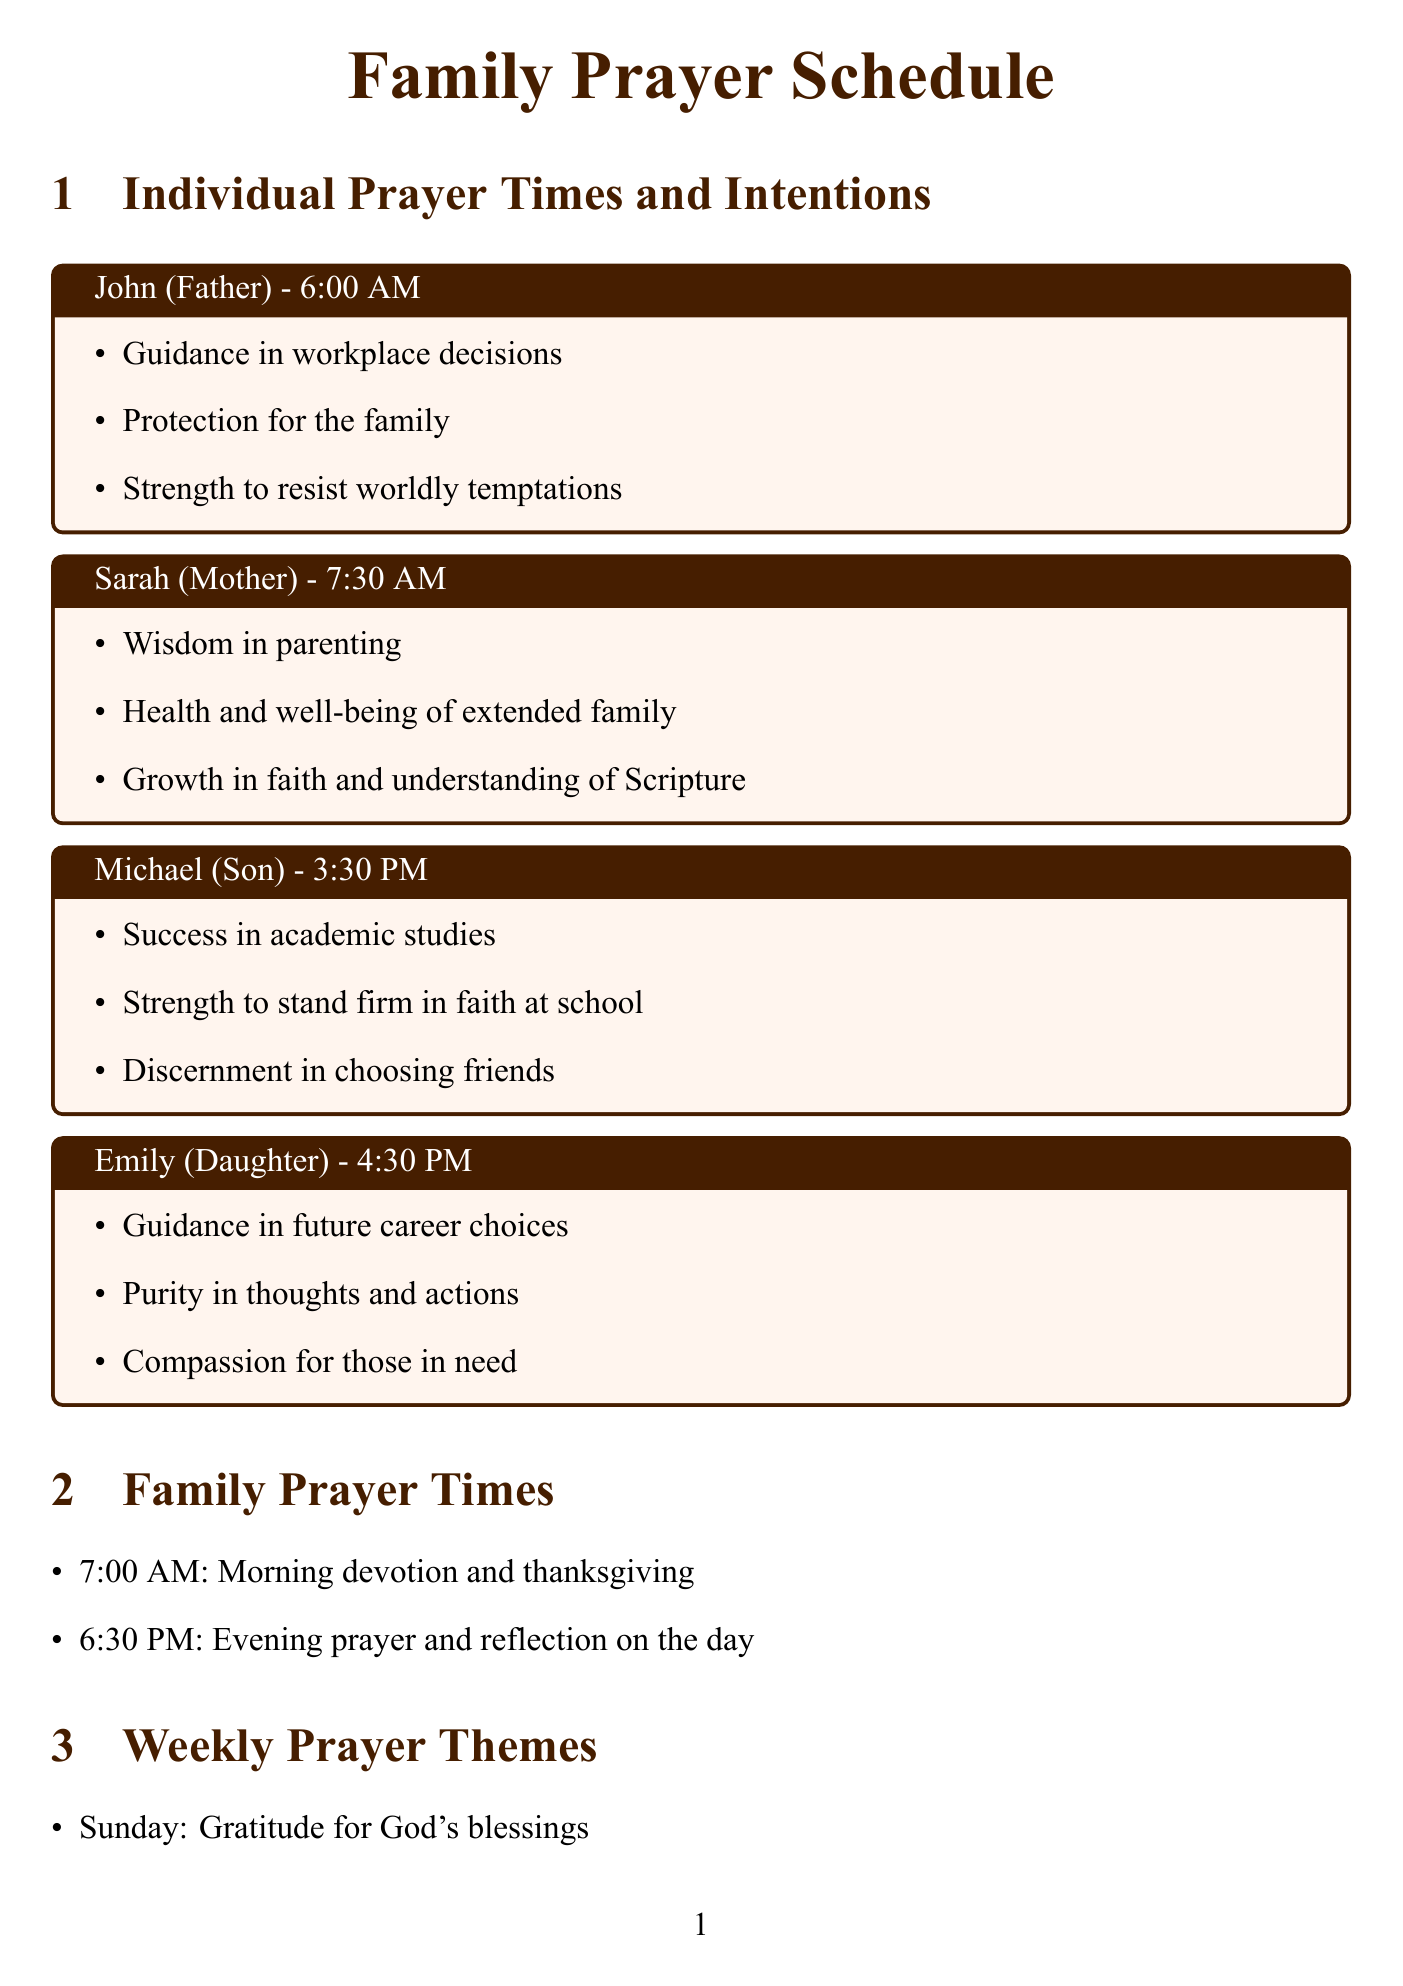What time does John pray? The document specifies John's prayer time is at 6:00 AM.
Answer: 6:00 AM What is the focus of the evening family prayer? The document states the focus for the evening prayer at 6:30 PM is reflection on the day.
Answer: Reflection on the day What is the theme for Wednesday? The document lists the theme for Wednesday as spiritual growth and understanding of the Bible.
Answer: Spiritual growth and understanding of the Bible Which family member's intention includes "Success in academic studies"? The intention is associated with Michael, the Son.
Answer: Michael How often is the monthly family fasting day? The document indicates that the monthly family fasting day is on the first Saturday of each month.
Answer: Monthly What resource is suggested for morning inspiration? The document specifies "Our Daily Bread devotional" for morning inspiration.
Answer: Our Daily Bread devotional What is the prayer intention for non-believing family members? The document mentions the intention for non-believing family members is to pray for them.
Answer: Non-believing friends and family members On which day is the theme "Service to others and spreading God's word"? According to the document, this theme is assigned to Saturday.
Answer: Saturday 